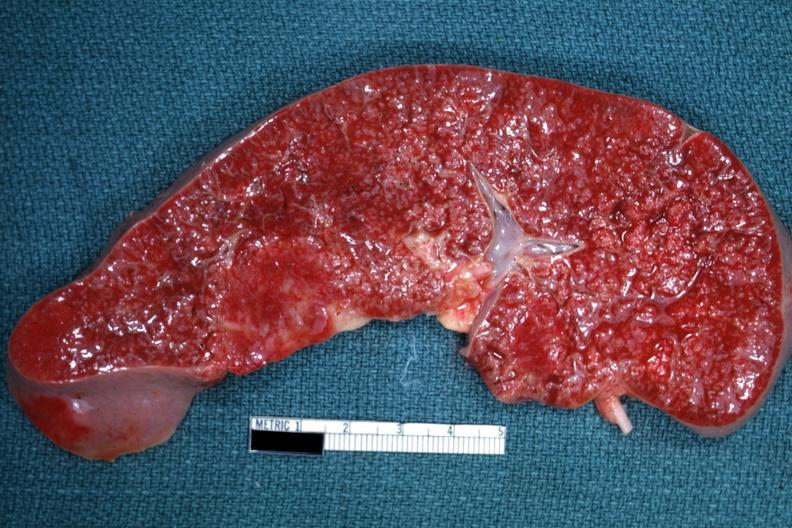s pituitectomy present?
Answer the question using a single word or phrase. No 